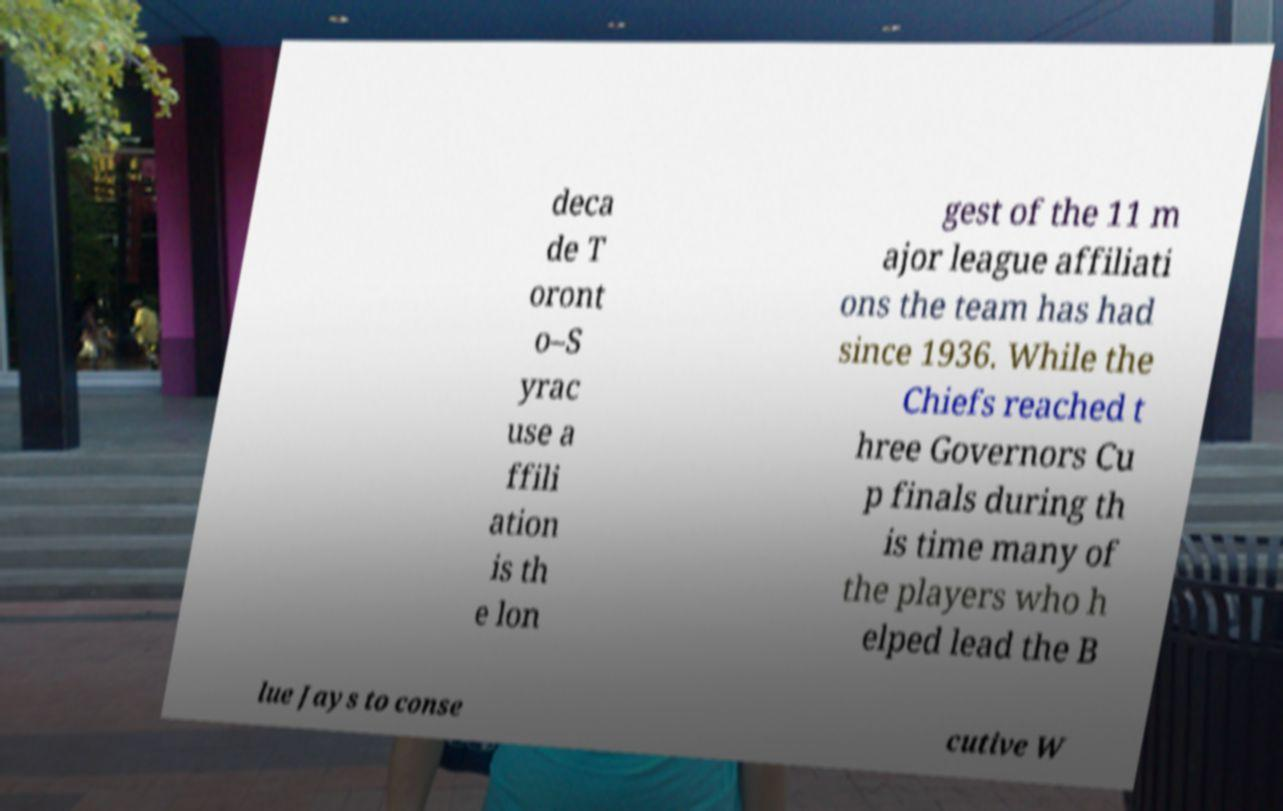For documentation purposes, I need the text within this image transcribed. Could you provide that? deca de T oront o–S yrac use a ffili ation is th e lon gest of the 11 m ajor league affiliati ons the team has had since 1936. While the Chiefs reached t hree Governors Cu p finals during th is time many of the players who h elped lead the B lue Jays to conse cutive W 